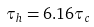<formula> <loc_0><loc_0><loc_500><loc_500>\tau _ { h } = 6 . 1 6 \tau _ { c }</formula> 